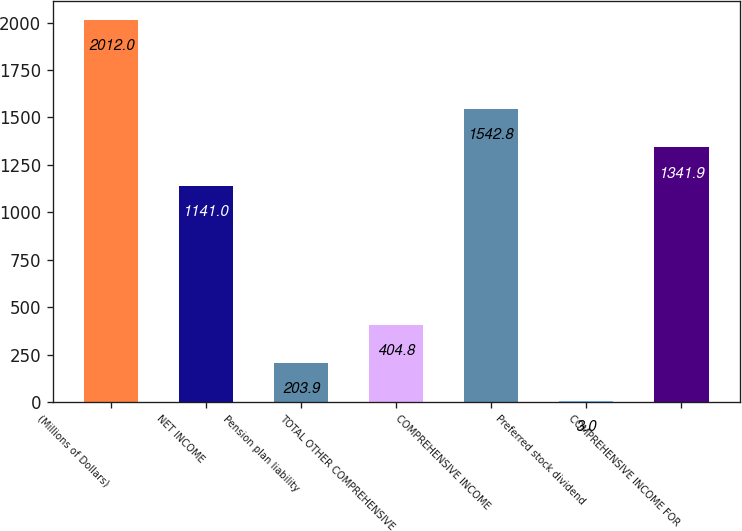Convert chart. <chart><loc_0><loc_0><loc_500><loc_500><bar_chart><fcel>(Millions of Dollars)<fcel>NET INCOME<fcel>Pension plan liability<fcel>TOTAL OTHER COMPREHENSIVE<fcel>COMPREHENSIVE INCOME<fcel>Preferred stock dividend<fcel>COMPREHENSIVE INCOME FOR<nl><fcel>2012<fcel>1141<fcel>203.9<fcel>404.8<fcel>1542.8<fcel>3<fcel>1341.9<nl></chart> 